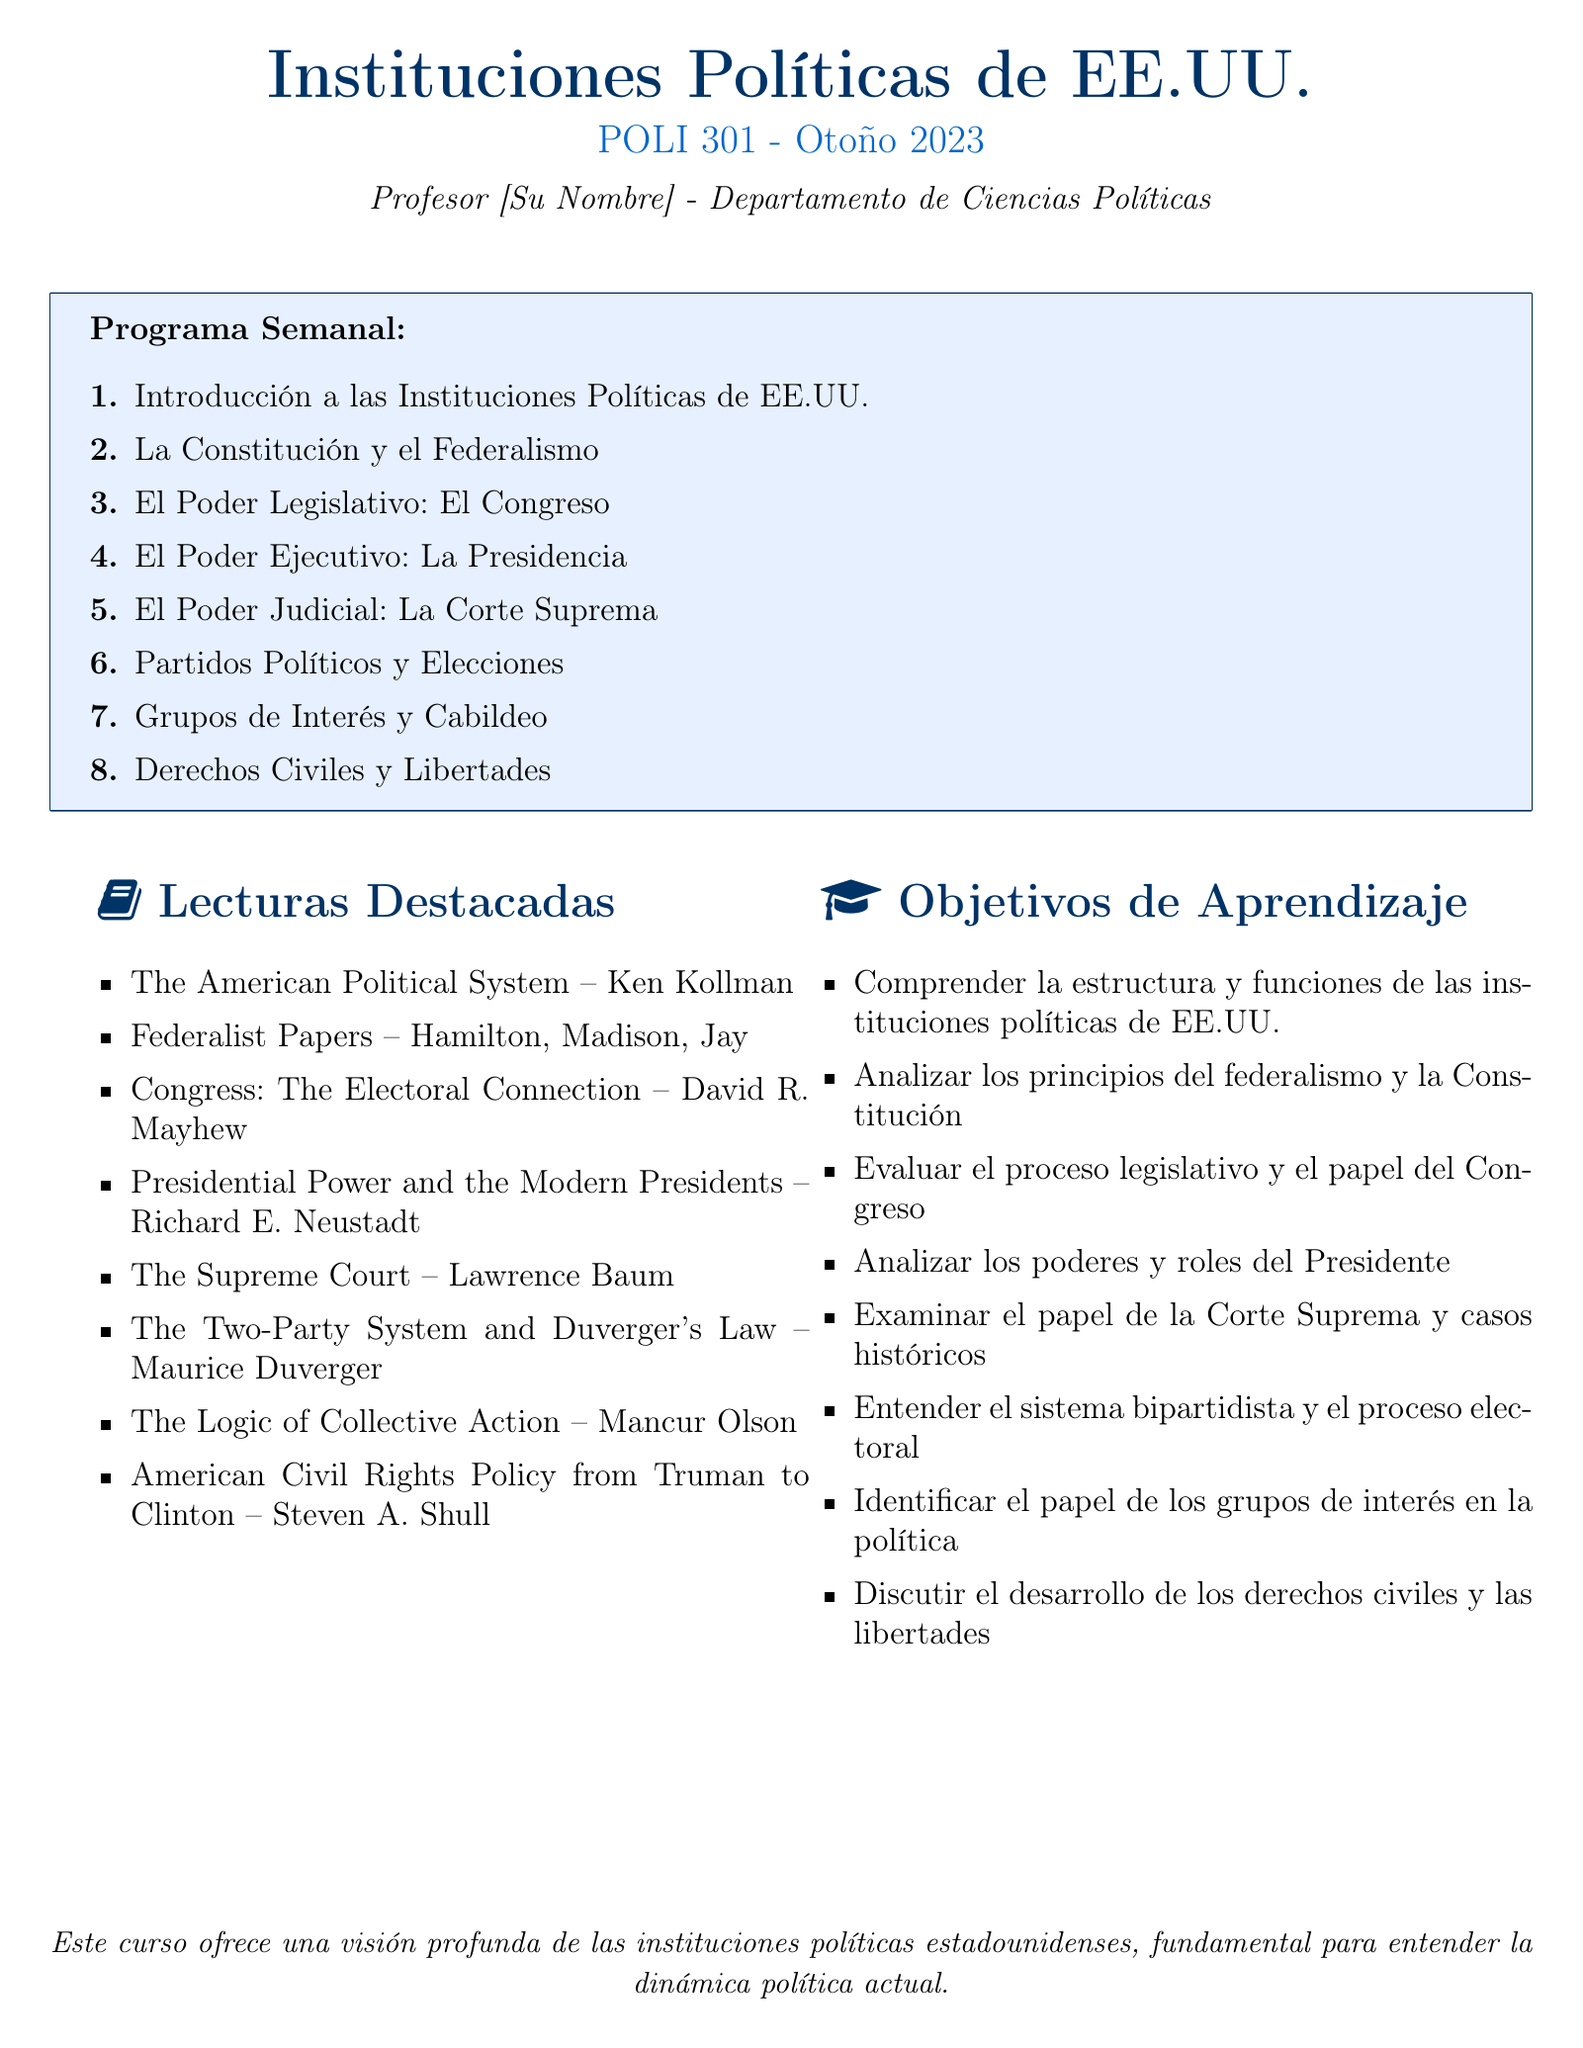¿Cuántas semanas dura el curso? El curso abarca ocho temas, lo que implica una duración de ocho semanas.
Answer: Ocho semanas ¿Quién es el autor del libro "The American Political System"? Ken Kollman es el autor mencionado en el documento para esa lectura en particular.
Answer: Ken Kollman ¿Cuál es el título del cuarto tema semanal? El cuarto tema se centra en "El Poder Ejecutivo: La Presidencia".
Answer: El Poder Ejecutivo: La Presidencia ¿Cuál es uno de los objetivos de aprendizaje del curso? Uno de los objetivos es "Comprender la estructura y funciones de las instituciones políticas de EE.UU.".
Answer: Comprender la estructura y funciones de las instituciones políticas de EE.UU ¿Cuántos autores escribieron los Federalist Papers? Los Federalist Papers fueron escritos por tres autores.
Answer: Tres autores ¿Qué libro de lectura se centra en la conexión electoral del Congreso? El libro que se centra en esa temática es "Congress: The Electoral Connection".
Answer: Congress: The Electoral Connection ¿Cuál es el tema del séptimo título semanal? El séptimo título aborda "Grupos de Interés y Cabildeo".
Answer: Grupos de Interés y Cabildeo ¿Qué es el curso POLI 301? El curso POLI 301 se trata de "Instituciones Políticas de EE.UU.".
Answer: Instituciones Políticas de EE.UU ¿Qué documento analiza los derechos civiles en EE.UU. desde Truman hasta Clinton? El documento que se menciona es "American Civil Rights Policy from Truman to Clinton".
Answer: American Civil Rights Policy from Truman to Clinton 